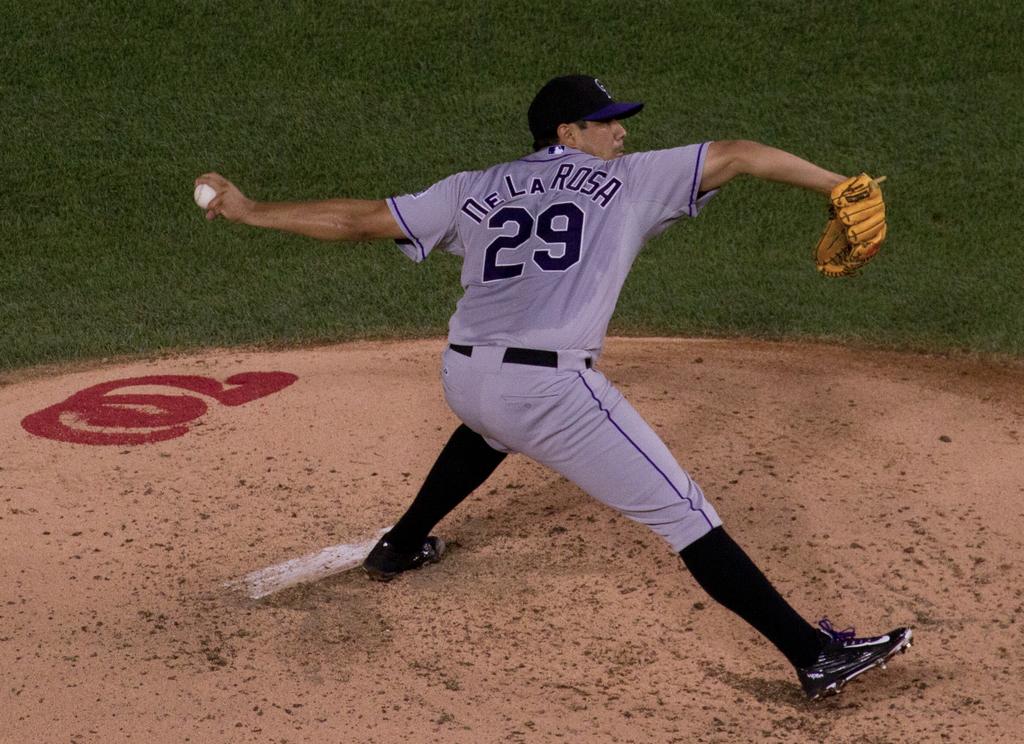What is the number of the player?
Offer a terse response. 29. 